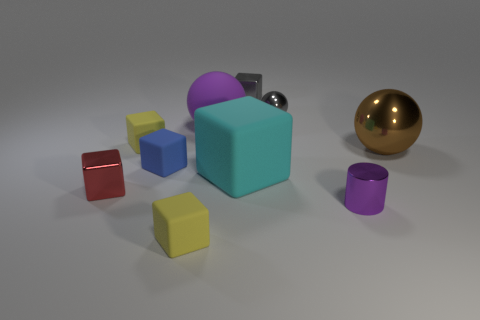Does the small metallic ball have the same color as the big shiny object?
Offer a very short reply. No. What number of gray metal spheres are to the left of the blue block in front of the big sphere left of the brown thing?
Provide a succinct answer. 0. What is the yellow cube in front of the small yellow rubber cube that is on the left side of the blue rubber cube to the left of the brown shiny object made of?
Give a very brief answer. Rubber. Is the yellow block that is behind the large shiny sphere made of the same material as the brown ball?
Offer a terse response. No. How many gray blocks have the same size as the rubber ball?
Your response must be concise. 0. Are there more tiny red objects that are behind the large cyan matte cube than large brown metal spheres in front of the red thing?
Keep it short and to the point. No. Is there a red object of the same shape as the large purple rubber object?
Keep it short and to the point. No. There is a metallic thing left of the metal object that is behind the tiny gray metal sphere; what size is it?
Keep it short and to the point. Small. What shape is the small yellow matte object behind the shiny block to the left of the metallic block that is behind the big brown object?
Offer a very short reply. Cube. There is a purple thing that is made of the same material as the small blue block; what size is it?
Your answer should be very brief. Large. 